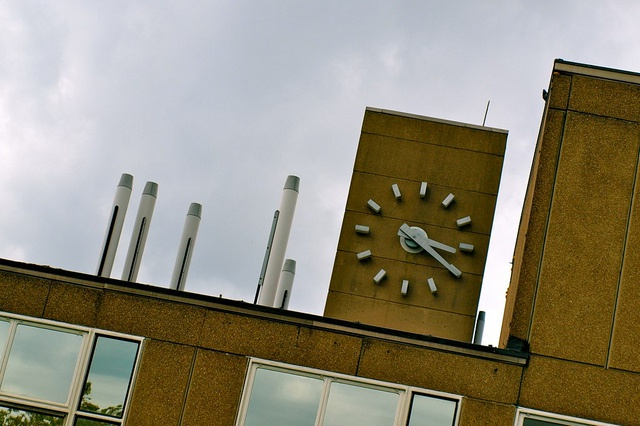Describe the objects in this image and their specific colors. I can see a clock in lightgray, olive, black, and darkgray tones in this image. 